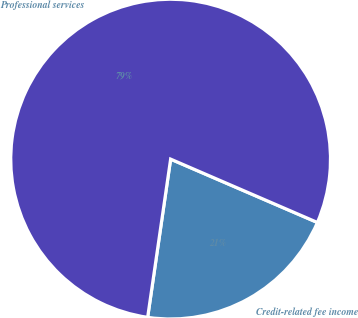<chart> <loc_0><loc_0><loc_500><loc_500><pie_chart><fcel>Credit-related fee income<fcel>Professional services<nl><fcel>20.81%<fcel>79.19%<nl></chart> 